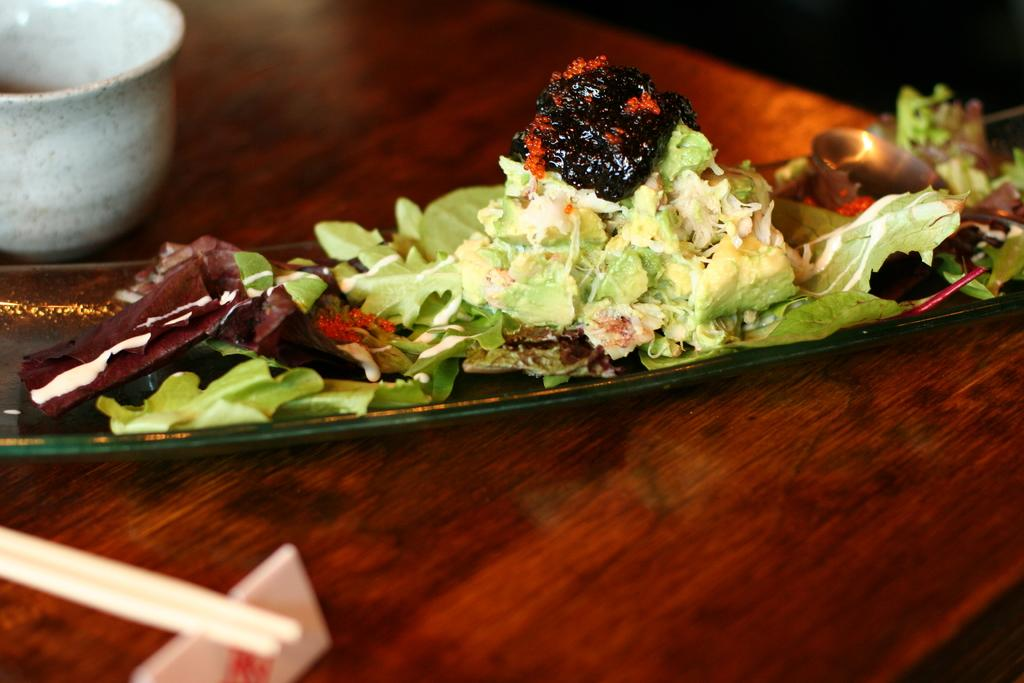What is present on the object in the image? There is food on an object in the image. What is the object placed on? The object is on a wooden surface. What utensils are visible on the wooden surface? There are chopsticks on the wooden surface. What else can be found on the wooden surface? There is a cup on the wooden surface. What type of government is depicted on the calendar in the image? There is no calendar present in the image, so it is not possible to determine the type of government depicted. 